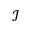<formula> <loc_0><loc_0><loc_500><loc_500>\mathcal { I }</formula> 